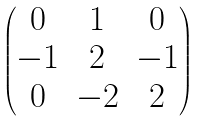Convert formula to latex. <formula><loc_0><loc_0><loc_500><loc_500>\begin{pmatrix} 0 & 1 & 0 \\ - 1 & 2 & - 1 \\ 0 & - 2 & 2 \end{pmatrix}</formula> 